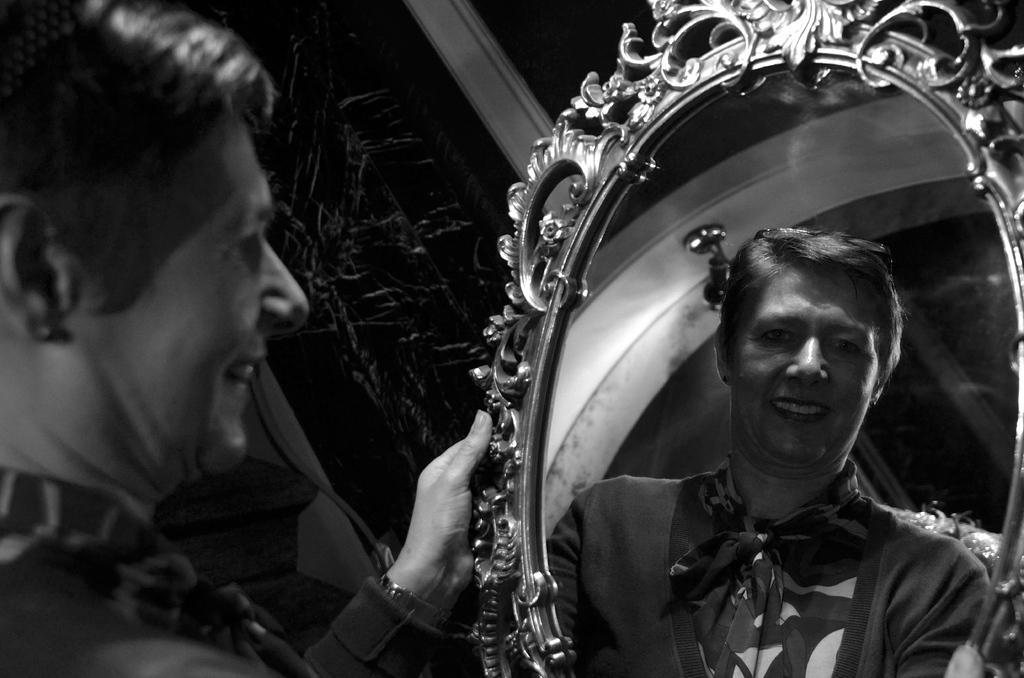Describe this image in one or two sentences. This is a black and white image. In this image we can a woman holding a mirror. We can also see the reflected image of that woman in a mirror. 